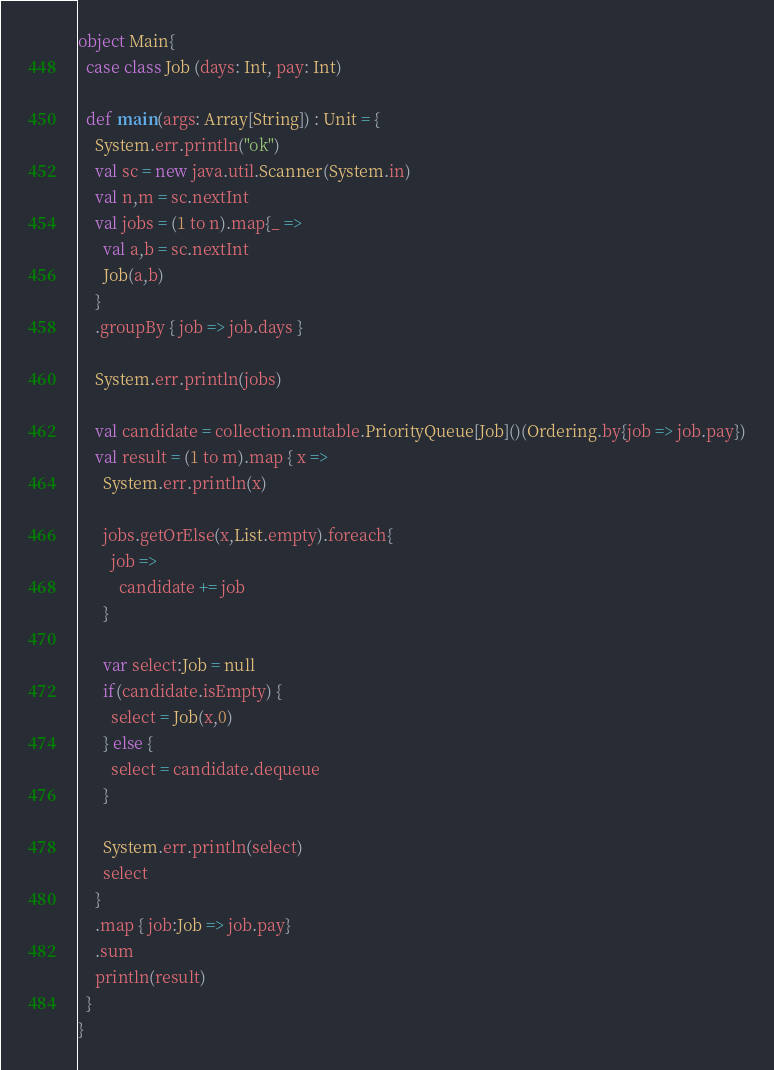<code> <loc_0><loc_0><loc_500><loc_500><_Scala_>object Main{
  case class Job (days: Int, pay: Int)

  def main(args: Array[String]) : Unit = {
    System.err.println("ok")
    val sc = new java.util.Scanner(System.in)
    val n,m = sc.nextInt
    val jobs = (1 to n).map{_ => 
      val a,b = sc.nextInt
      Job(a,b)
    }
    .groupBy { job => job.days }

    System.err.println(jobs)

    val candidate = collection.mutable.PriorityQueue[Job]()(Ordering.by{job => job.pay})
    val result = (1 to m).map { x =>
      System.err.println(x)

      jobs.getOrElse(x,List.empty).foreach{
        job => 
          candidate += job
      }

      var select:Job = null
      if(candidate.isEmpty) {
        select = Job(x,0)
      } else {
        select = candidate.dequeue
      }

      System.err.println(select)
      select
    }
    .map { job:Job => job.pay}
    .sum
    println(result)
  }
}

</code> 